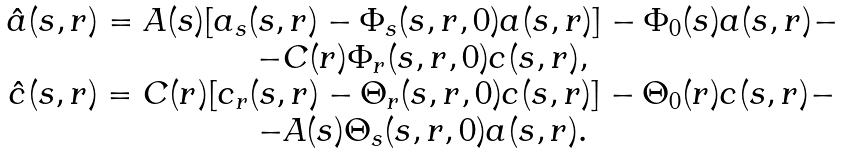Convert formula to latex. <formula><loc_0><loc_0><loc_500><loc_500>\begin{array} { c } \hat { a } ( s , r ) = A ( s ) [ a _ { s } ( s , r ) - \Phi _ { s } ( s , r , 0 ) a ( s , r ) ] - \Phi _ { 0 } ( s ) a ( s , r ) - \\ - C ( r ) \Phi _ { r } ( s , r , 0 ) c ( s , r ) , \\ \hat { c } ( s , r ) = C ( r ) [ c _ { r } ( s , r ) - \Theta _ { r } ( s , r , 0 ) c ( s , r ) ] - \Theta _ { 0 } ( r ) c ( s , r ) - \\ - A ( s ) \Theta _ { s } ( s , r , 0 ) a ( s , r ) . \end{array}</formula> 